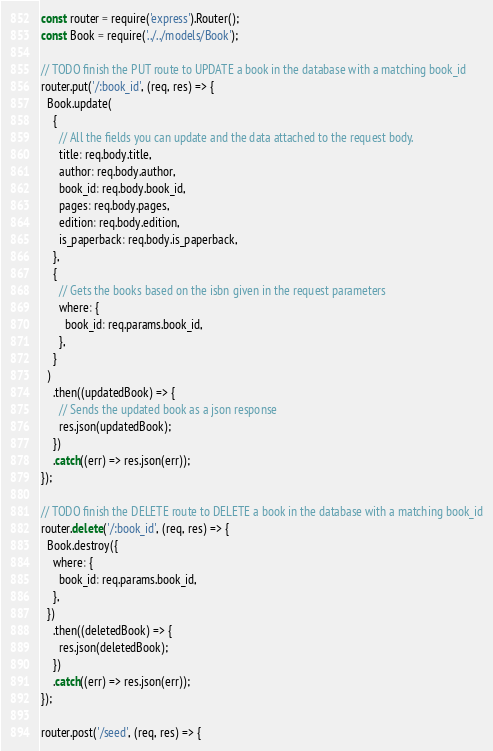<code> <loc_0><loc_0><loc_500><loc_500><_JavaScript_>const router = require('express').Router();
const Book = require('../../models/Book');

// TODO finish the PUT route to UPDATE a book in the database with a matching book_id
router.put('/:book_id', (req, res) => {
  Book.update(
    {
      // All the fields you can update and the data attached to the request body.
      title: req.body.title,
      author: req.body.author,
      book_id: req.body.book_id,
      pages: req.body.pages,
      edition: req.body.edition,
      is_paperback: req.body.is_paperback,
    },
    {
      // Gets the books based on the isbn given in the request parameters
      where: {
        book_id: req.params.book_id,
      },
    }
  )
    .then((updatedBook) => {
      // Sends the updated book as a json response
      res.json(updatedBook);
    })
    .catch((err) => res.json(err));
});

// TODO finish the DELETE route to DELETE a book in the database with a matching book_id
router.delete('/:book_id', (req, res) => {
  Book.destroy({
    where: {
      book_id: req.params.book_id,
    },
  })
    .then((deletedBook) => {
      res.json(deletedBook);
    })
    .catch((err) => res.json(err));
});

router.post('/seed', (req, res) => {</code> 